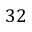Convert formula to latex. <formula><loc_0><loc_0><loc_500><loc_500>3 2</formula> 